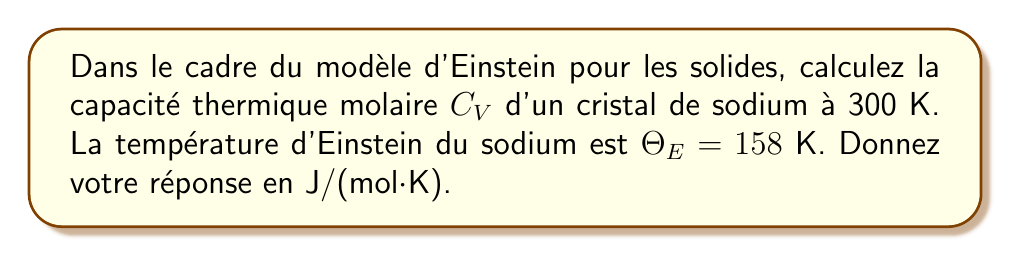Can you solve this math problem? Pour résoudre ce problème, nous allons suivre ces étapes :

1) Dans le modèle d'Einstein, la capacité thermique molaire $C_V$ est donnée par la formule :

   $$C_V = 3R \left(\frac{\Theta_E}{T}\right)^2 \frac{e^{\Theta_E/T}}{(e^{\Theta_E/T}-1)^2}$$

   où $R$ est la constante des gaz parfaits (8,314 J/(mol·K)), $\Theta_E$ est la température d'Einstein, et $T$ est la température du cristal.

2) Nous avons les données suivantes :
   $\Theta_E = 158$ K
   $T = 300$ K

3) Calculons d'abord le rapport $\Theta_E/T$ :
   
   $$\frac{\Theta_E}{T} = \frac{158}{300} = 0,5267$$

4) Maintenant, calculons $e^{\Theta_E/T}$ :
   
   $$e^{0,5267} = 1,6933$$

5) Substituons ces valeurs dans l'équation :

   $$C_V = 3 \cdot 8,314 \cdot (0,5267)^2 \cdot \frac{1,6933}{(1,6933-1)^2}$$

6) Calculons :
   
   $$C_V = 24,942 \cdot 0,2774 \cdot \frac{1,6933}{0,4804} = 24,11 \text{ J/(mol·K)}$$

7) Arrondissons à deux décimales :

   $$C_V \approx 24,11 \text{ J/(mol·K)}$$
Answer: 24,11 J/(mol·K) 